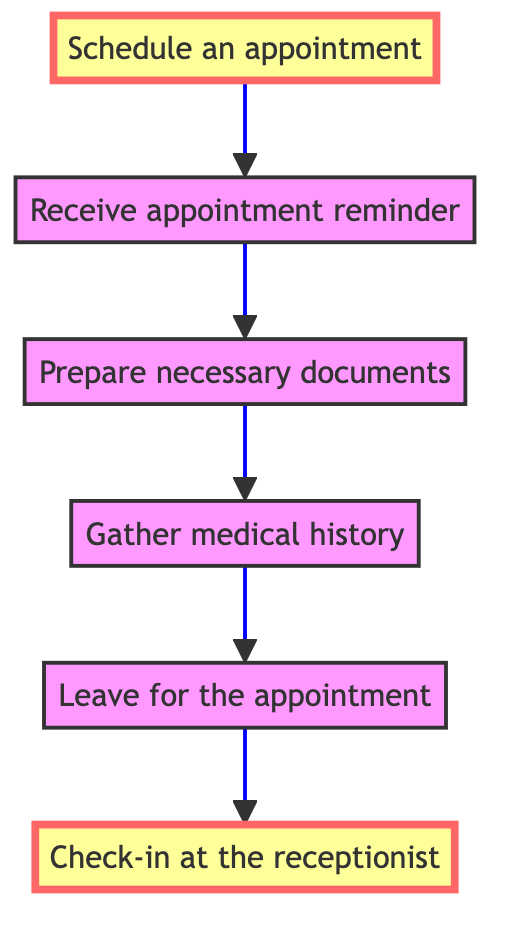What is the first step in the appointment scheduling process? The first step is "Schedule an appointment," which is indicated at the bottom of the flowchart.
Answer: Schedule an appointment How many total steps are in the flowchart? By counting each distinct node in the diagram, there are a total of six steps.
Answer: Six What follows after receiving an appointment reminder? After the appointment reminder, the next step is to "Prepare necessary documents," as indicated in the sequential flow.
Answer: Prepare necessary documents What do you need to gather before leaving for the appointment? You need to gather "medical history," which is listed before the step of leaving for the appointment.
Answer: Medical history What is the last step before checking in at the receptionist? The step immediately before checking in at the receptionist is "Leave for the appointment," which shows the order of actions to take before arrival.
Answer: Leave for the appointment What are the highlighted steps in the flowchart? The highlighted steps are "Schedule an appointment" and "Check-in at the receptionist," which are made distinct for emphasis in the diagram.
Answer: Schedule an appointment and Check-in at the receptionist What documents are necessary to prepare before the appointment? You need to prepare necessary documents including a photo ID, insurance card, and a list of current medications, as stated in the flowchart.
Answer: Photo ID, insurance card, list of current medications Which step requires confirming your appointment? The step "Receive appointment reminder" involves confirming your appointment if required, as indicated by the flow of tasks.
Answer: Receive appointment reminder Which step details contacting the doctor’s office? The step where you call the doctor's office or use the online portal to schedule your appointment details this process, highlighted as the first step in the flow.
Answer: Schedule an appointment 